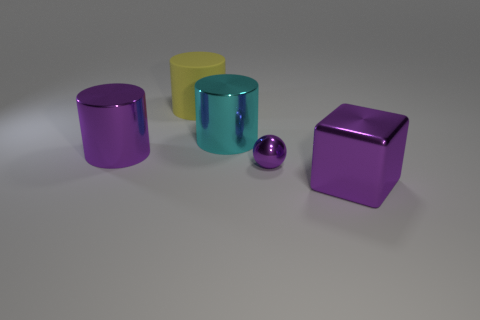Add 1 matte cylinders. How many matte cylinders exist? 2 Add 5 large brown metal spheres. How many objects exist? 10 Subtract all cyan cylinders. How many cylinders are left? 2 Subtract all large yellow cylinders. How many cylinders are left? 2 Subtract 0 brown cylinders. How many objects are left? 5 Subtract all cubes. How many objects are left? 4 Subtract 1 spheres. How many spheres are left? 0 Subtract all red blocks. Subtract all yellow cylinders. How many blocks are left? 1 Subtract all blue balls. How many cyan cylinders are left? 1 Subtract all small yellow shiny objects. Subtract all big matte things. How many objects are left? 4 